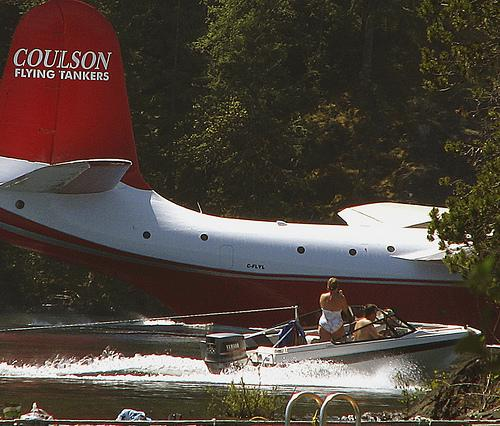Based on the circumstances of the image what method of transportation currently moves the fastest? Please explain your reasoning. motorboat. The motorboat is generating waves. 